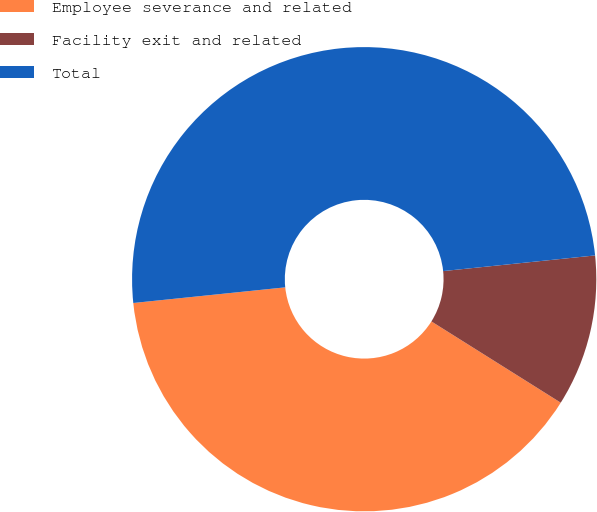Convert chart to OTSL. <chart><loc_0><loc_0><loc_500><loc_500><pie_chart><fcel>Employee severance and related<fcel>Facility exit and related<fcel>Total<nl><fcel>39.44%<fcel>10.56%<fcel>50.0%<nl></chart> 